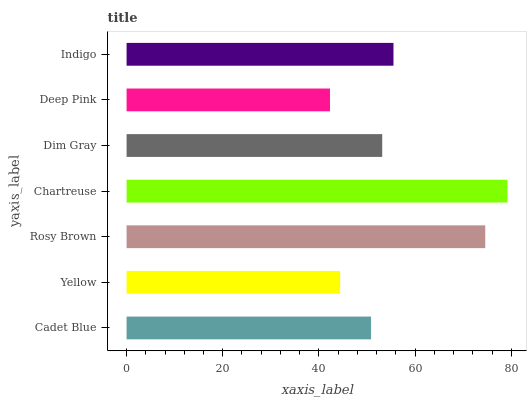Is Deep Pink the minimum?
Answer yes or no. Yes. Is Chartreuse the maximum?
Answer yes or no. Yes. Is Yellow the minimum?
Answer yes or no. No. Is Yellow the maximum?
Answer yes or no. No. Is Cadet Blue greater than Yellow?
Answer yes or no. Yes. Is Yellow less than Cadet Blue?
Answer yes or no. Yes. Is Yellow greater than Cadet Blue?
Answer yes or no. No. Is Cadet Blue less than Yellow?
Answer yes or no. No. Is Dim Gray the high median?
Answer yes or no. Yes. Is Dim Gray the low median?
Answer yes or no. Yes. Is Indigo the high median?
Answer yes or no. No. Is Rosy Brown the low median?
Answer yes or no. No. 